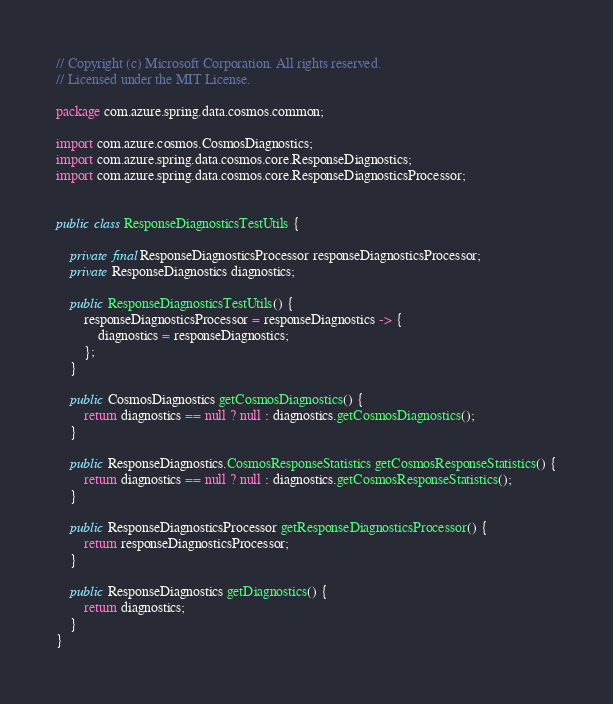<code> <loc_0><loc_0><loc_500><loc_500><_Java_>// Copyright (c) Microsoft Corporation. All rights reserved.
// Licensed under the MIT License.

package com.azure.spring.data.cosmos.common;

import com.azure.cosmos.CosmosDiagnostics;
import com.azure.spring.data.cosmos.core.ResponseDiagnostics;
import com.azure.spring.data.cosmos.core.ResponseDiagnosticsProcessor;


public class ResponseDiagnosticsTestUtils {

    private final ResponseDiagnosticsProcessor responseDiagnosticsProcessor;
    private ResponseDiagnostics diagnostics;

    public ResponseDiagnosticsTestUtils() {
        responseDiagnosticsProcessor = responseDiagnostics -> {
            diagnostics = responseDiagnostics;
        };
    }

    public CosmosDiagnostics getCosmosDiagnostics() {
        return diagnostics == null ? null : diagnostics.getCosmosDiagnostics();
    }

    public ResponseDiagnostics.CosmosResponseStatistics getCosmosResponseStatistics() {
        return diagnostics == null ? null : diagnostics.getCosmosResponseStatistics();
    }

    public ResponseDiagnosticsProcessor getResponseDiagnosticsProcessor() {
        return responseDiagnosticsProcessor;
    }

    public ResponseDiagnostics getDiagnostics() {
        return diagnostics;
    }
}
</code> 